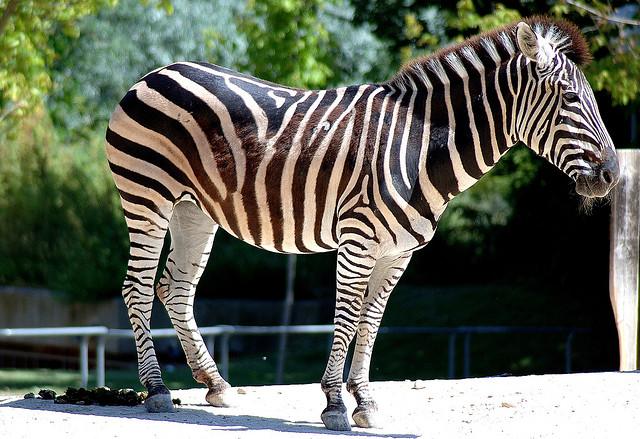Is that zebra making a bowel movement mess on the ground?
Keep it brief. Yes. Is this a female zebra?
Give a very brief answer. Yes. What is cast?
Short answer required. Shadow. 